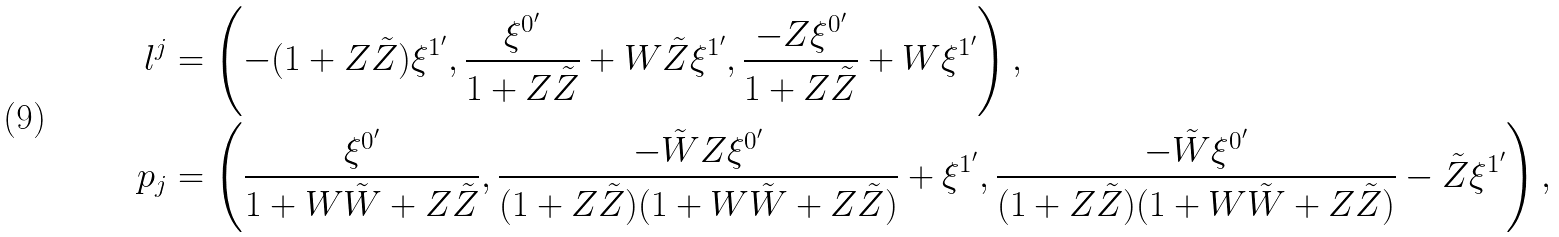<formula> <loc_0><loc_0><loc_500><loc_500>l ^ { j } & = \left ( - ( 1 + Z \tilde { Z } ) \xi ^ { 1 ^ { \prime } } , \frac { \xi ^ { 0 ^ { \prime } } } { 1 + Z \tilde { Z } } + W \tilde { Z } \xi ^ { 1 ^ { \prime } } , \frac { - Z \xi ^ { 0 ^ { \prime } } } { 1 + Z \tilde { Z } } + W \xi ^ { 1 ^ { \prime } } \right ) , \\ p _ { j } & = \left ( \frac { \xi ^ { 0 ^ { \prime } } } { 1 + W \tilde { W } + Z \tilde { Z } } , \frac { - \tilde { W } Z \xi ^ { 0 ^ { \prime } } } { ( 1 + Z \tilde { Z } ) ( 1 + W \tilde { W } + Z \tilde { Z } ) } + \xi ^ { 1 ^ { \prime } } , \frac { - \tilde { W } \xi ^ { 0 ^ { \prime } } } { ( 1 + Z \tilde { Z } ) ( 1 + W \tilde { W } + Z \tilde { Z } ) } - \tilde { Z } \xi ^ { 1 ^ { \prime } } \right ) ,</formula> 